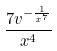Convert formula to latex. <formula><loc_0><loc_0><loc_500><loc_500>\frac { 7 v ^ { - \frac { 1 } { x ^ { 7 } } } } { x ^ { 4 } }</formula> 